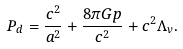<formula> <loc_0><loc_0><loc_500><loc_500>P _ { d } = \frac { c ^ { 2 } } { a ^ { 2 } } + \frac { 8 \pi G p } { c ^ { 2 } } + c ^ { 2 } \Lambda _ { v } .</formula> 